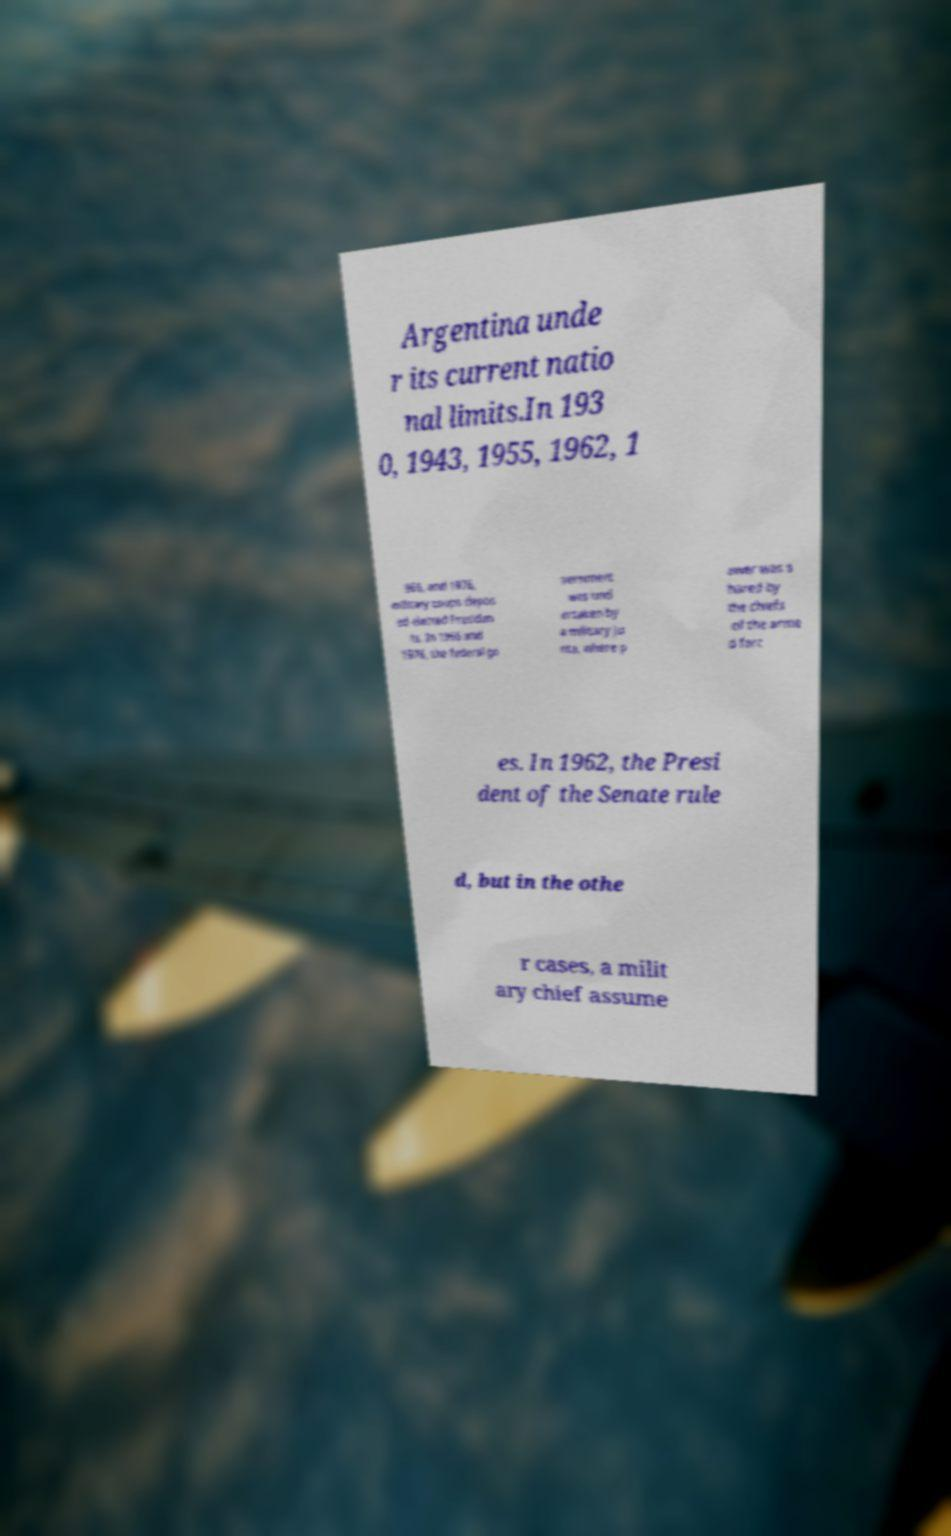Please identify and transcribe the text found in this image. Argentina unde r its current natio nal limits.In 193 0, 1943, 1955, 1962, 1 966, and 1976, military coups depos ed elected Presiden ts. In 1966 and 1976, the federal go vernment was und ertaken by a military ju nta, where p ower was s hared by the chiefs of the arme d forc es. In 1962, the Presi dent of the Senate rule d, but in the othe r cases, a milit ary chief assume 